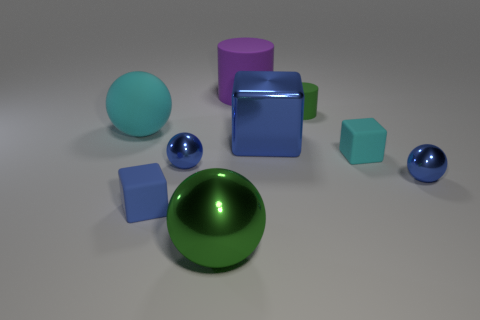There is a small metal sphere on the right side of the purple rubber object; how many matte cubes are behind it?
Give a very brief answer. 1. Is there a green matte thing on the left side of the tiny blue object on the right side of the small cyan block?
Offer a very short reply. Yes. There is a big blue shiny thing; are there any large cyan matte things behind it?
Your answer should be compact. Yes. There is a tiny blue rubber thing that is in front of the small cyan cube; is it the same shape as the small green thing?
Give a very brief answer. No. What number of small blue objects have the same shape as the small cyan rubber object?
Provide a succinct answer. 1. Is there a tiny blue thing that has the same material as the big cube?
Your response must be concise. Yes. What is the material of the large object that is to the left of the rubber cube that is on the left side of the green cylinder?
Provide a succinct answer. Rubber. There is a cylinder that is in front of the purple cylinder; what size is it?
Give a very brief answer. Small. There is a metallic block; is its color the same as the tiny rubber block that is on the left side of the cyan matte cube?
Your answer should be very brief. Yes. Are there any other cubes that have the same color as the large metal block?
Provide a succinct answer. Yes. 